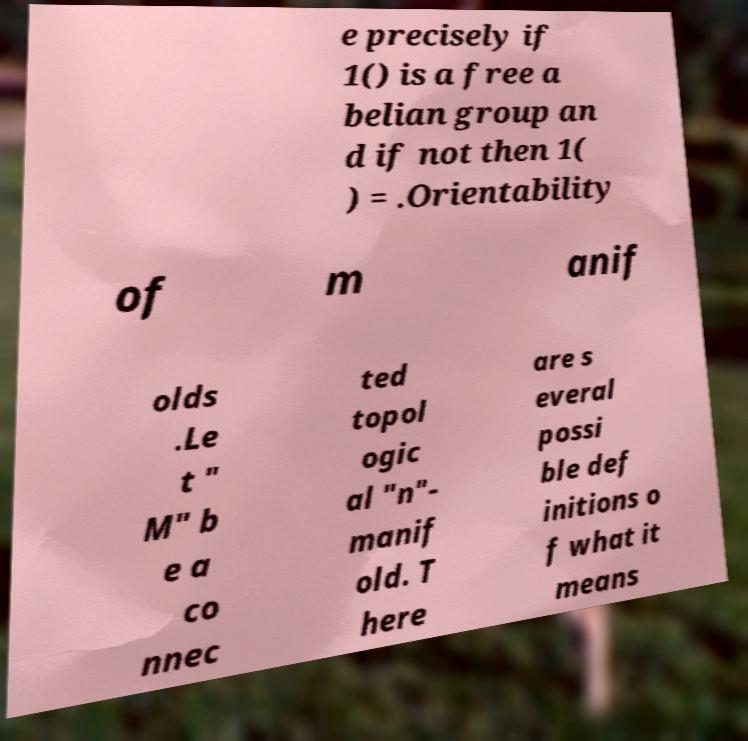Could you extract and type out the text from this image? e precisely if 1() is a free a belian group an d if not then 1( ) = .Orientability of m anif olds .Le t " M" b e a co nnec ted topol ogic al "n"- manif old. T here are s everal possi ble def initions o f what it means 